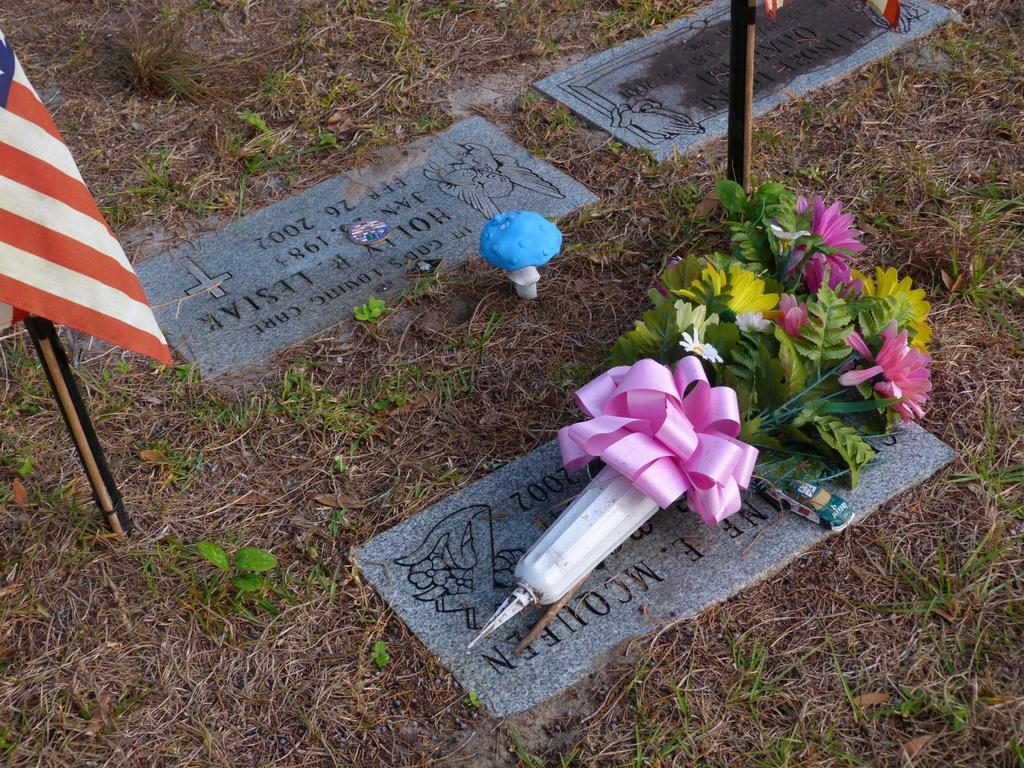Could you give a brief overview of what you see in this image? In this image I can see the ground, some grass on the ground and three stones which are grey in color on the ground and I can see something is carved on the stones. I can see a flower bouquet, a flag and a mushroom on the ground. 